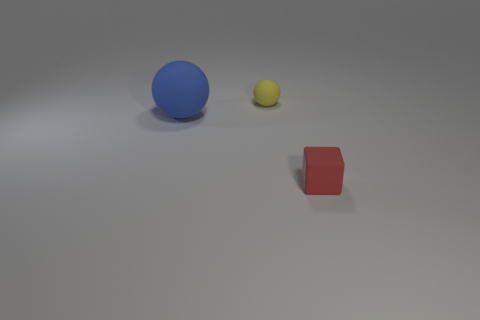How many small red metal cylinders are there?
Your answer should be very brief. 0. Are there any small red matte cubes to the left of the small red rubber cube?
Your answer should be compact. No. Is the material of the ball behind the blue matte object the same as the small thing in front of the large blue ball?
Your answer should be very brief. Yes. Is the number of tiny things left of the large ball less than the number of big green rubber cylinders?
Ensure brevity in your answer.  No. There is a rubber sphere that is behind the large blue rubber object; what color is it?
Your answer should be compact. Yellow. Is there a blue matte object that has the same size as the blue matte ball?
Provide a short and direct response. No. How many things are either large blue objects to the left of the red block or big blue objects that are left of the red block?
Give a very brief answer. 1. There is a matte thing that is on the right side of the small sphere; is its size the same as the matte object behind the blue matte ball?
Offer a very short reply. Yes. There is a tiny thing in front of the small rubber ball; are there any big blue rubber spheres in front of it?
Offer a very short reply. No. There is a blue matte sphere; how many small rubber objects are behind it?
Offer a very short reply. 1. 